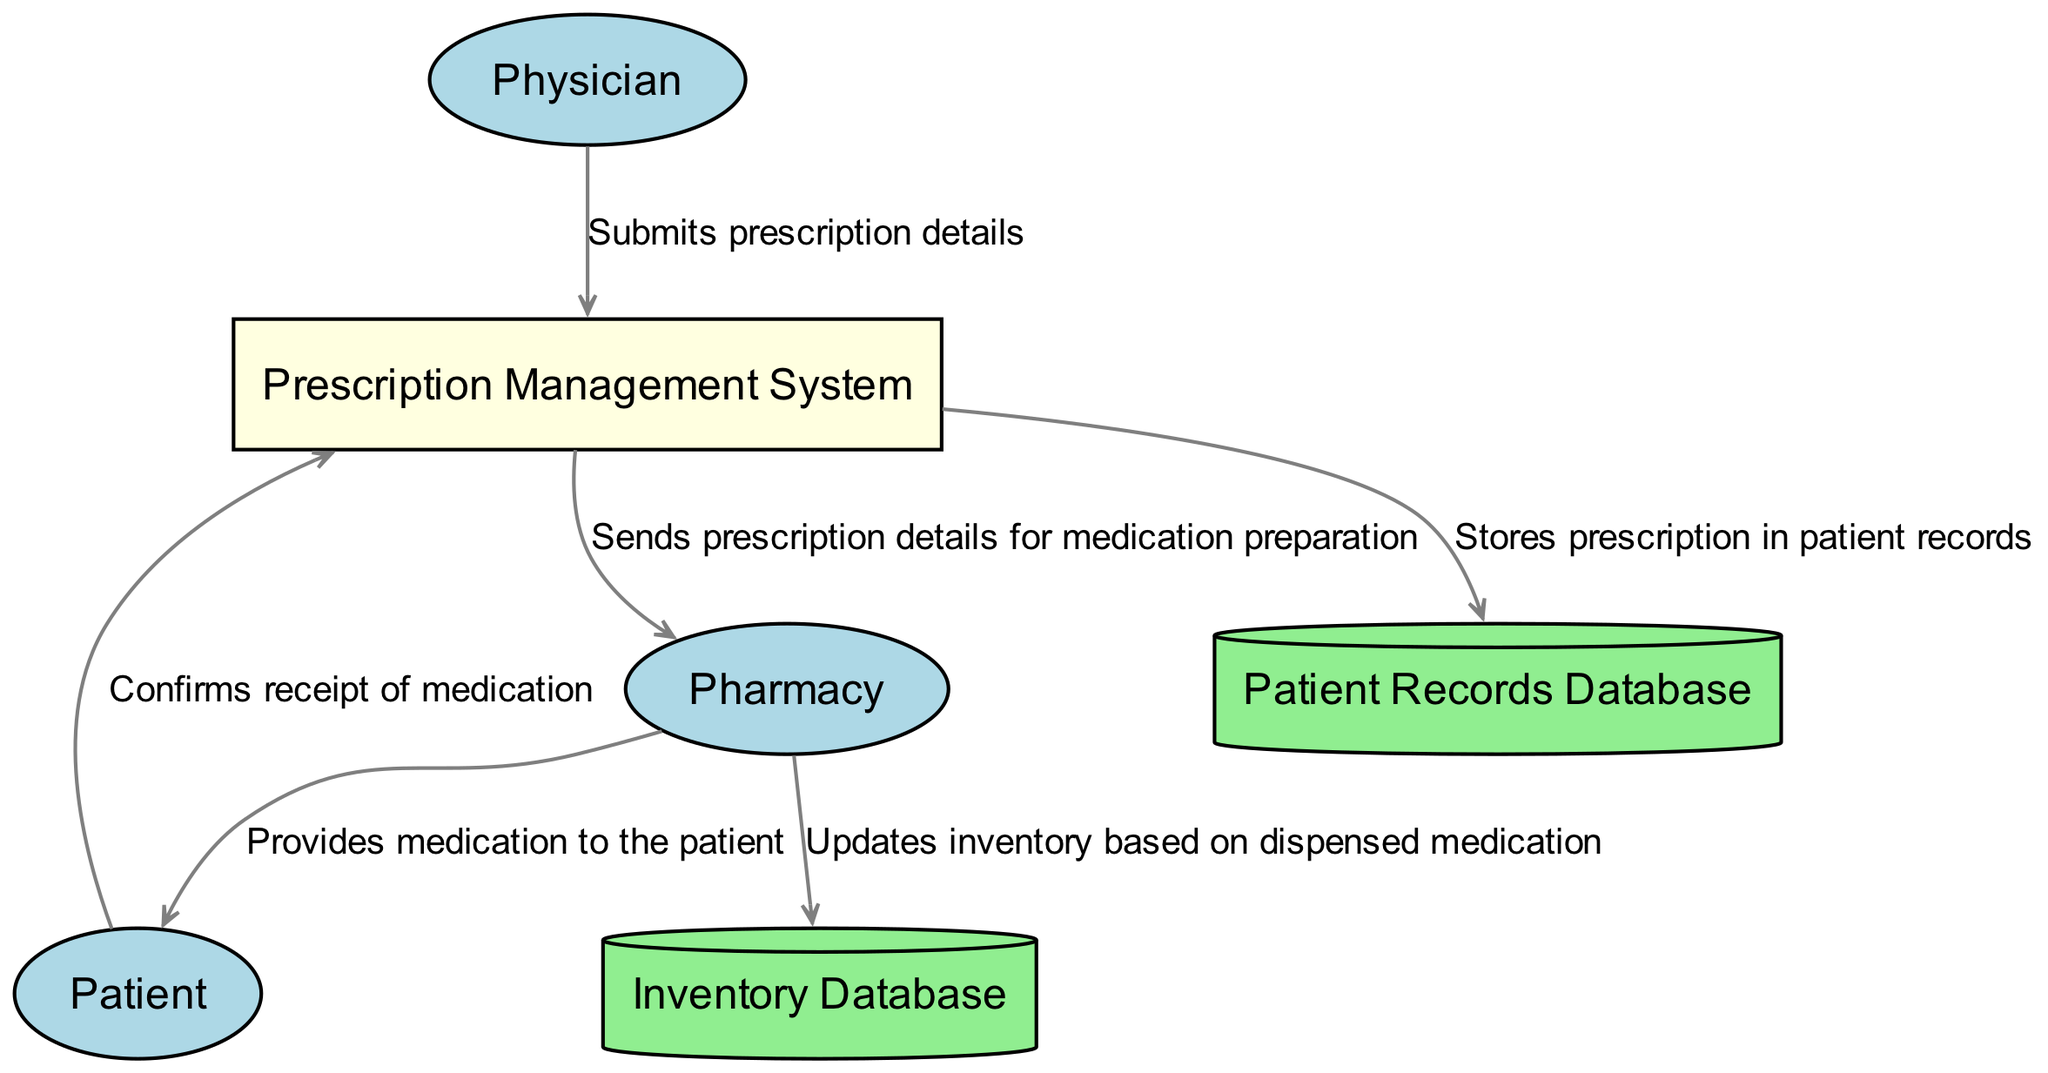What is the external entity that initiates the prescription process? The diagram shows "Physician" as the external entity responsible for initiating the prescription process by writing and submitting the prescription.
Answer: Physician How many data stores are represented in the diagram? The diagram displays two data stores: "Patient Records Database" and "Inventory Database". This can be confirmed by counting the cylinder shapes in the diagram.
Answer: 2 What type of flow occurs between the "Prescription Management System" and "Pharmacy"? A data flow labeled "Sends prescription details for medication preparation" connects "Prescription Management System" and "Pharmacy", indicating an information exchange for medication preparation.
Answer: Sends prescription details for medication preparation Which entity receives medication dispensed by the Pharmacy? The "Patient" entity is indicated as the one receiving the medication from the "Pharmacy", as evidenced by the data flow labeled "Provides medication to the patient".
Answer: Patient What does the "Pharmacy" update in the Inventory Database? The "Pharmacy" updates the "Inventory Database" based on the dispensed medication, as shown by the data flow labeled "Updates inventory based on dispensed medication".
Answer: Updates inventory based on dispensed medication How does the Prescription Management System interact with the Patient Records Database? The "Prescription Management System" stores the prescription in the "Patient Records Database", indicated by the data flow labeled "Stores prescription in patient records". This shows the interaction between the system and the database.
Answer: Stores prescription in patient records What confirms that the Patient received their medication? The "Patient" confirms receipt of medication to the "Prescription Management System", as indicated by the data flow labeled "Confirms receipt of medication". This establishes a feedback mechanism.
Answer: Confirms receipt of medication What type of entity is the Prescription Management System? The "Prescription Management System" is classified as a Process in the diagram, as represented by the rectangular shape which indicates its role in managing data processing and flow.
Answer: Process 